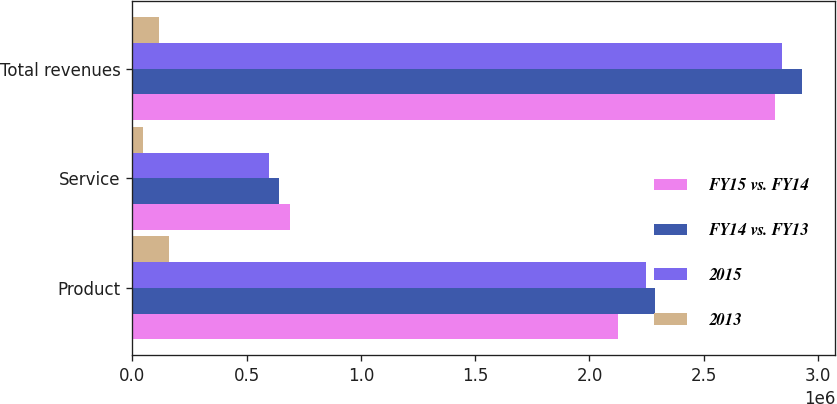Convert chart. <chart><loc_0><loc_0><loc_500><loc_500><stacked_bar_chart><ecel><fcel>Product<fcel>Service<fcel>Total revenues<nl><fcel>FY15 vs. FY14<fcel>2.1254e+06<fcel>688653<fcel>2.81405e+06<nl><fcel>FY14 vs. FY13<fcel>2.28644e+06<fcel>642971<fcel>2.92941e+06<nl><fcel>2015<fcel>2.24715e+06<fcel>595634<fcel>2.84278e+06<nl><fcel>2013<fcel>161041<fcel>45682<fcel>115359<nl></chart> 